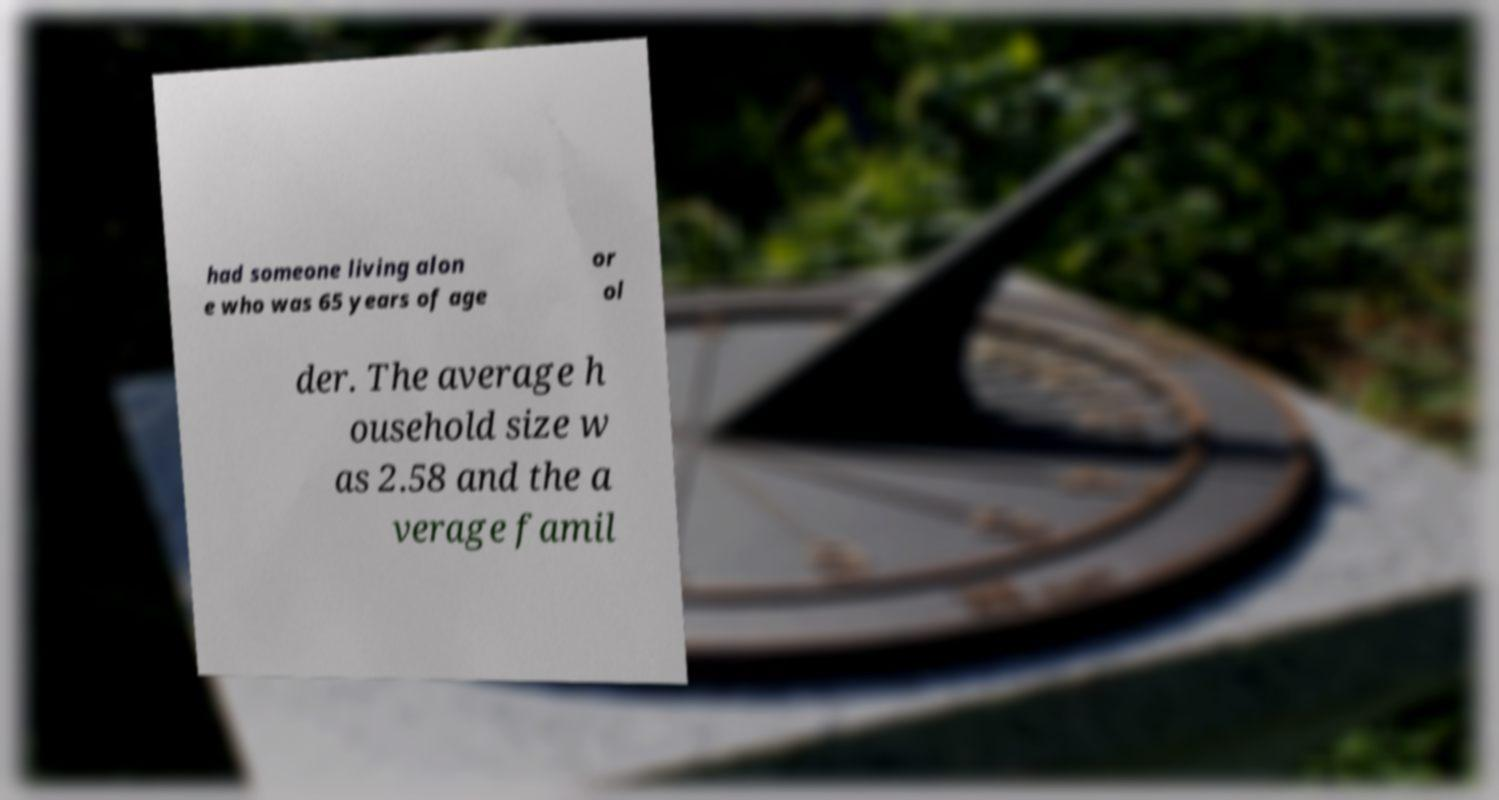Could you extract and type out the text from this image? had someone living alon e who was 65 years of age or ol der. The average h ousehold size w as 2.58 and the a verage famil 